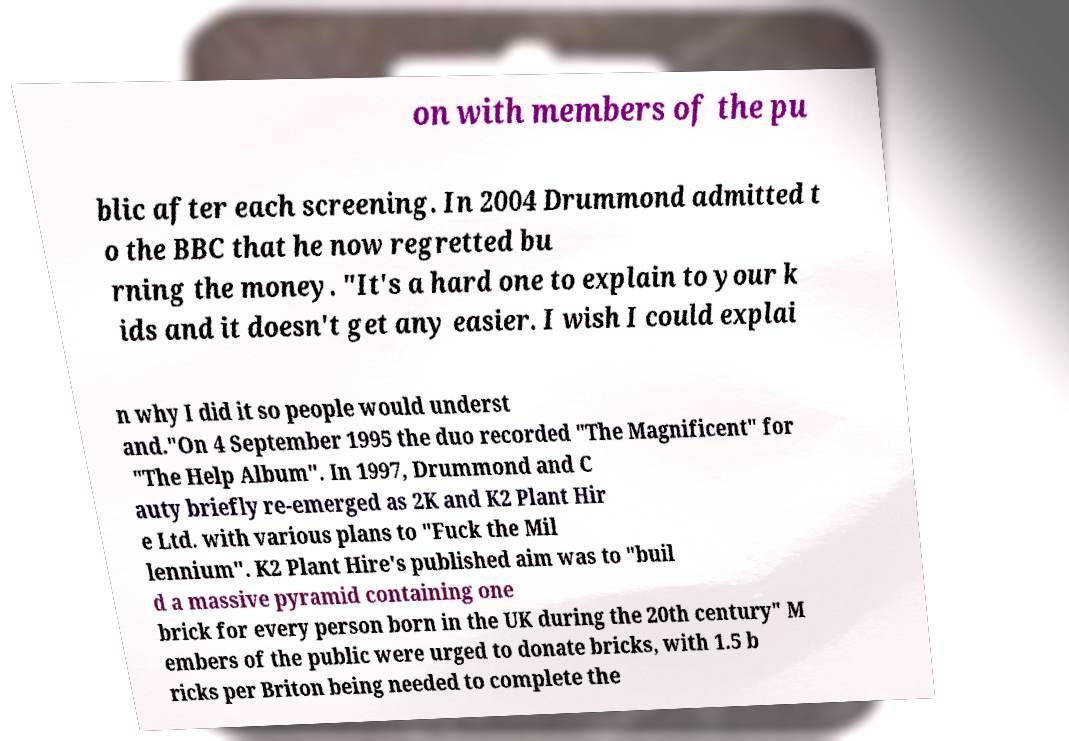Can you read and provide the text displayed in the image?This photo seems to have some interesting text. Can you extract and type it out for me? on with members of the pu blic after each screening. In 2004 Drummond admitted t o the BBC that he now regretted bu rning the money. "It's a hard one to explain to your k ids and it doesn't get any easier. I wish I could explai n why I did it so people would underst and."On 4 September 1995 the duo recorded "The Magnificent" for "The Help Album". In 1997, Drummond and C auty briefly re-emerged as 2K and K2 Plant Hir e Ltd. with various plans to "Fuck the Mil lennium". K2 Plant Hire's published aim was to "buil d a massive pyramid containing one brick for every person born in the UK during the 20th century" M embers of the public were urged to donate bricks, with 1.5 b ricks per Briton being needed to complete the 